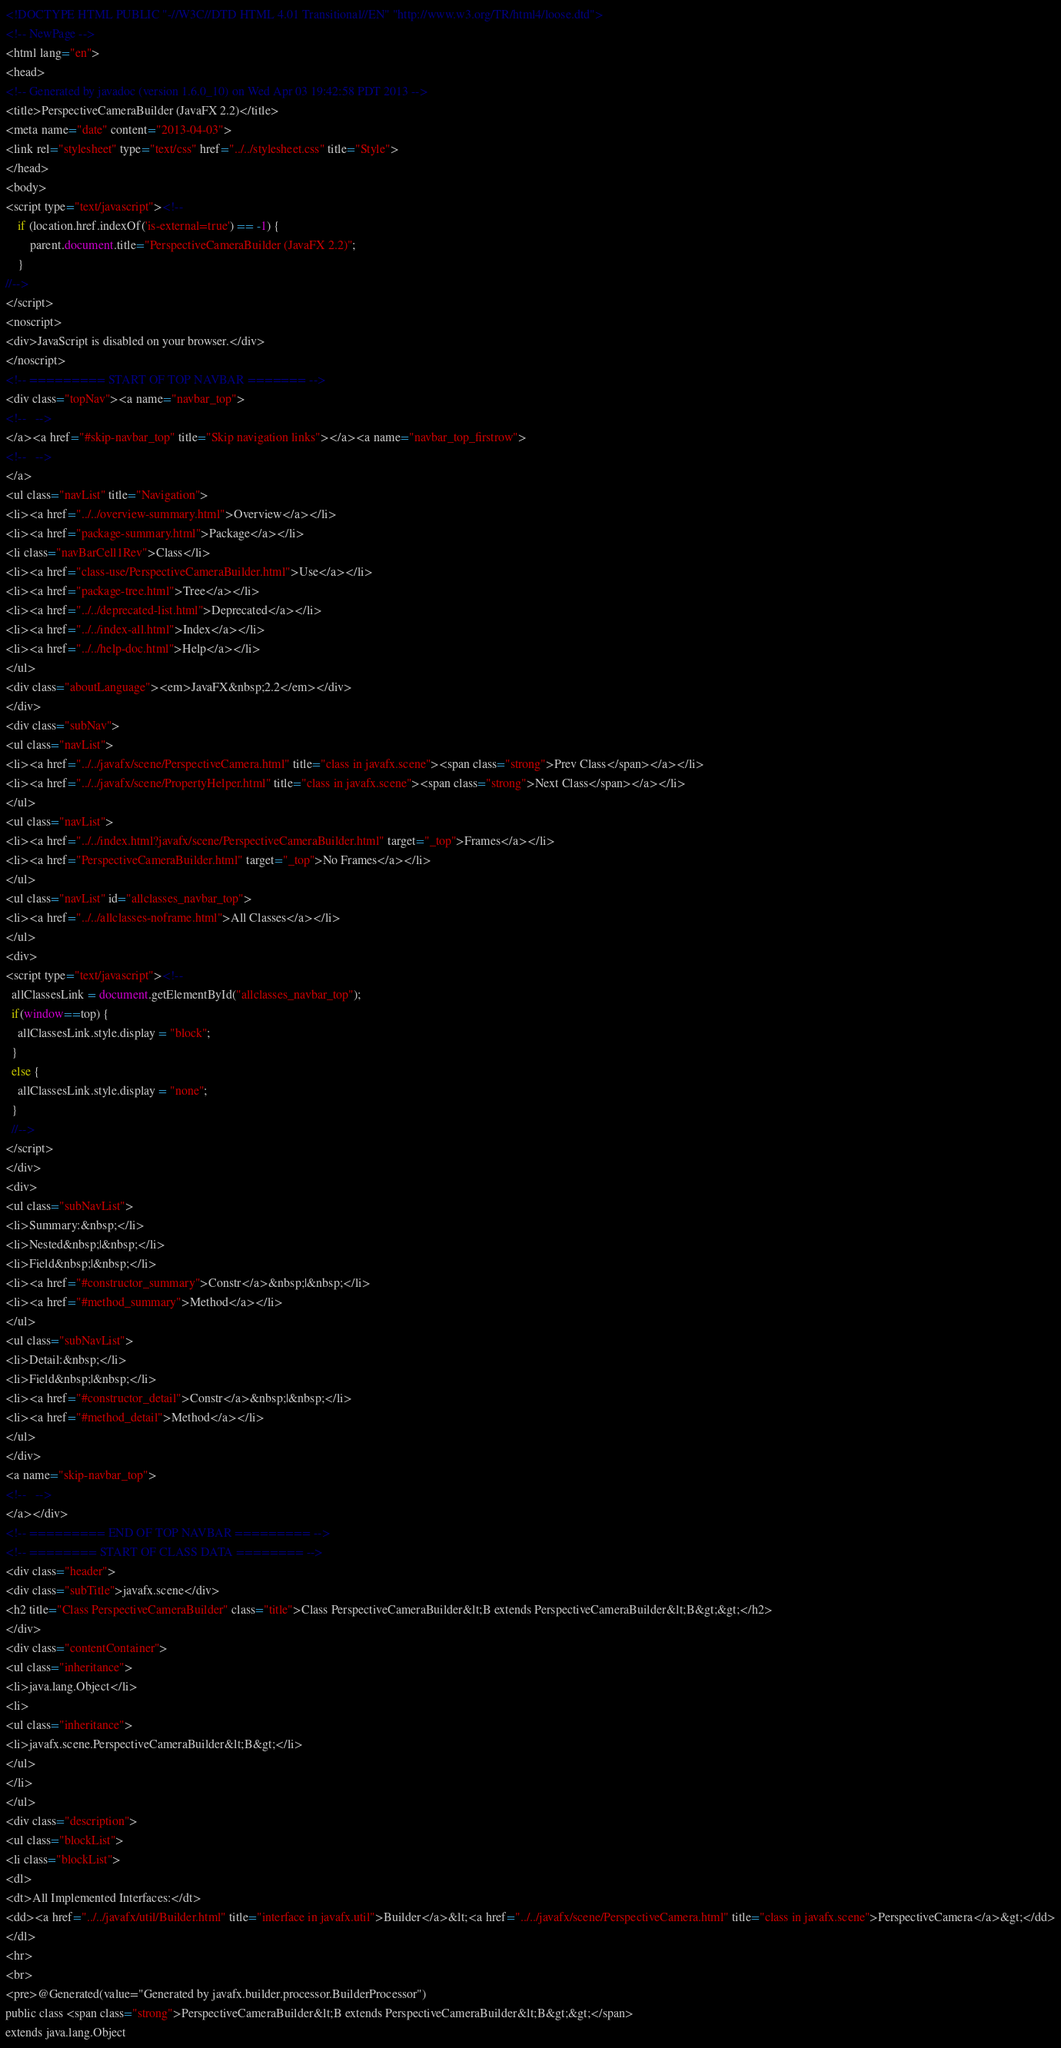Convert code to text. <code><loc_0><loc_0><loc_500><loc_500><_HTML_><!DOCTYPE HTML PUBLIC "-//W3C//DTD HTML 4.01 Transitional//EN" "http://www.w3.org/TR/html4/loose.dtd">
<!-- NewPage -->
<html lang="en">
<head>
<!-- Generated by javadoc (version 1.6.0_10) on Wed Apr 03 19:42:58 PDT 2013 -->
<title>PerspectiveCameraBuilder (JavaFX 2.2)</title>
<meta name="date" content="2013-04-03">
<link rel="stylesheet" type="text/css" href="../../stylesheet.css" title="Style">
</head>
<body>
<script type="text/javascript"><!--
    if (location.href.indexOf('is-external=true') == -1) {
        parent.document.title="PerspectiveCameraBuilder (JavaFX 2.2)";
    }
//-->
</script>
<noscript>
<div>JavaScript is disabled on your browser.</div>
</noscript>
<!-- ========= START OF TOP NAVBAR ======= -->
<div class="topNav"><a name="navbar_top">
<!--   -->
</a><a href="#skip-navbar_top" title="Skip navigation links"></a><a name="navbar_top_firstrow">
<!--   -->
</a>
<ul class="navList" title="Navigation">
<li><a href="../../overview-summary.html">Overview</a></li>
<li><a href="package-summary.html">Package</a></li>
<li class="navBarCell1Rev">Class</li>
<li><a href="class-use/PerspectiveCameraBuilder.html">Use</a></li>
<li><a href="package-tree.html">Tree</a></li>
<li><a href="../../deprecated-list.html">Deprecated</a></li>
<li><a href="../../index-all.html">Index</a></li>
<li><a href="../../help-doc.html">Help</a></li>
</ul>
<div class="aboutLanguage"><em>JavaFX&nbsp;2.2</em></div>
</div>
<div class="subNav">
<ul class="navList">
<li><a href="../../javafx/scene/PerspectiveCamera.html" title="class in javafx.scene"><span class="strong">Prev Class</span></a></li>
<li><a href="../../javafx/scene/PropertyHelper.html" title="class in javafx.scene"><span class="strong">Next Class</span></a></li>
</ul>
<ul class="navList">
<li><a href="../../index.html?javafx/scene/PerspectiveCameraBuilder.html" target="_top">Frames</a></li>
<li><a href="PerspectiveCameraBuilder.html" target="_top">No Frames</a></li>
</ul>
<ul class="navList" id="allclasses_navbar_top">
<li><a href="../../allclasses-noframe.html">All Classes</a></li>
</ul>
<div>
<script type="text/javascript"><!--
  allClassesLink = document.getElementById("allclasses_navbar_top");
  if(window==top) {
    allClassesLink.style.display = "block";
  }
  else {
    allClassesLink.style.display = "none";
  }
  //-->
</script>
</div>
<div>
<ul class="subNavList">
<li>Summary:&nbsp;</li>
<li>Nested&nbsp;|&nbsp;</li>
<li>Field&nbsp;|&nbsp;</li>
<li><a href="#constructor_summary">Constr</a>&nbsp;|&nbsp;</li>
<li><a href="#method_summary">Method</a></li>
</ul>
<ul class="subNavList">
<li>Detail:&nbsp;</li>
<li>Field&nbsp;|&nbsp;</li>
<li><a href="#constructor_detail">Constr</a>&nbsp;|&nbsp;</li>
<li><a href="#method_detail">Method</a></li>
</ul>
</div>
<a name="skip-navbar_top">
<!--   -->
</a></div>
<!-- ========= END OF TOP NAVBAR ========= -->
<!-- ======== START OF CLASS DATA ======== -->
<div class="header">
<div class="subTitle">javafx.scene</div>
<h2 title="Class PerspectiveCameraBuilder" class="title">Class PerspectiveCameraBuilder&lt;B extends PerspectiveCameraBuilder&lt;B&gt;&gt;</h2>
</div>
<div class="contentContainer">
<ul class="inheritance">
<li>java.lang.Object</li>
<li>
<ul class="inheritance">
<li>javafx.scene.PerspectiveCameraBuilder&lt;B&gt;</li>
</ul>
</li>
</ul>
<div class="description">
<ul class="blockList">
<li class="blockList">
<dl>
<dt>All Implemented Interfaces:</dt>
<dd><a href="../../javafx/util/Builder.html" title="interface in javafx.util">Builder</a>&lt;<a href="../../javafx/scene/PerspectiveCamera.html" title="class in javafx.scene">PerspectiveCamera</a>&gt;</dd>
</dl>
<hr>
<br>
<pre>@Generated(value="Generated by javafx.builder.processor.BuilderProcessor")
public class <span class="strong">PerspectiveCameraBuilder&lt;B extends PerspectiveCameraBuilder&lt;B&gt;&gt;</span>
extends java.lang.Object</code> 